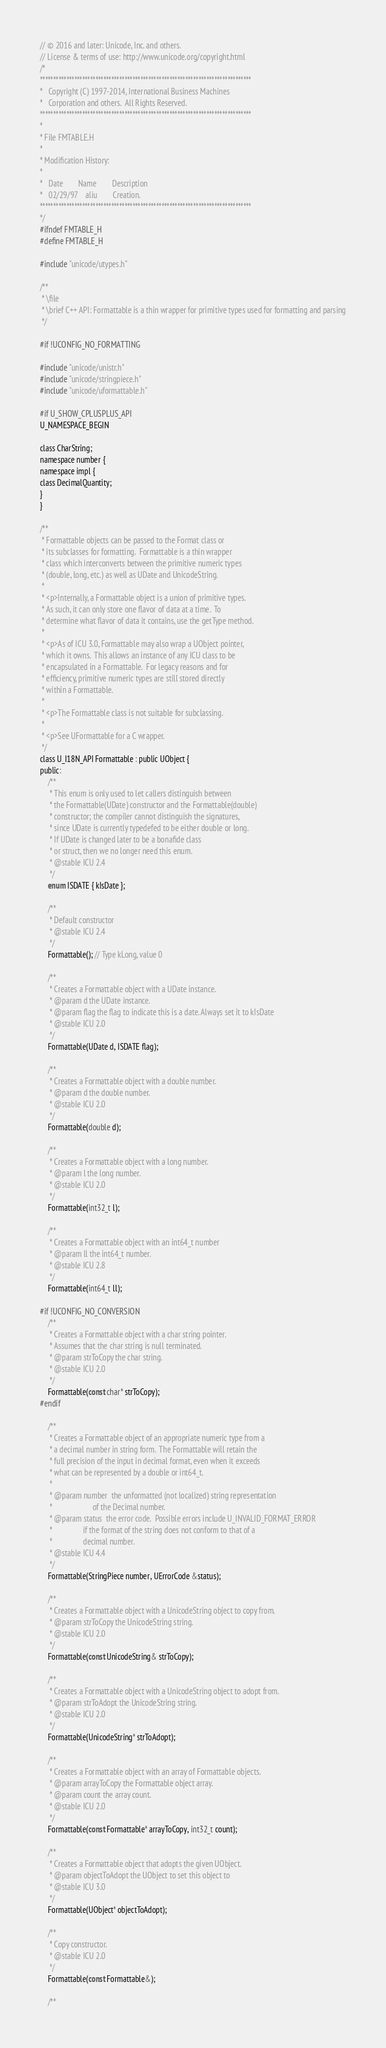Convert code to text. <code><loc_0><loc_0><loc_500><loc_500><_C_>// © 2016 and later: Unicode, Inc. and others.
// License & terms of use: http://www.unicode.org/copyright.html
/*
********************************************************************************
*   Copyright (C) 1997-2014, International Business Machines
*   Corporation and others.  All Rights Reserved.
********************************************************************************
*
* File FMTABLE.H
*
* Modification History:
*
*   Date        Name        Description
*   02/29/97    aliu        Creation.
********************************************************************************
*/
#ifndef FMTABLE_H
#define FMTABLE_H

#include "unicode/utypes.h"

/**
 * \file
 * \brief C++ API: Formattable is a thin wrapper for primitive types used for formatting and parsing
 */

#if !UCONFIG_NO_FORMATTING

#include "unicode/unistr.h"
#include "unicode/stringpiece.h"
#include "unicode/uformattable.h"

#if U_SHOW_CPLUSPLUS_API
U_NAMESPACE_BEGIN

class CharString;
namespace number {
namespace impl {
class DecimalQuantity;
}
}

/**
 * Formattable objects can be passed to the Format class or
 * its subclasses for formatting.  Formattable is a thin wrapper
 * class which interconverts between the primitive numeric types
 * (double, long, etc.) as well as UDate and UnicodeString.
 *
 * <p>Internally, a Formattable object is a union of primitive types.
 * As such, it can only store one flavor of data at a time.  To
 * determine what flavor of data it contains, use the getType method.
 *
 * <p>As of ICU 3.0, Formattable may also wrap a UObject pointer,
 * which it owns.  This allows an instance of any ICU class to be
 * encapsulated in a Formattable.  For legacy reasons and for
 * efficiency, primitive numeric types are still stored directly
 * within a Formattable.
 *
 * <p>The Formattable class is not suitable for subclassing.
 *
 * <p>See UFormattable for a C wrapper.
 */
class U_I18N_API Formattable : public UObject {
public:
    /**
     * This enum is only used to let callers distinguish between
     * the Formattable(UDate) constructor and the Formattable(double)
     * constructor; the compiler cannot distinguish the signatures,
     * since UDate is currently typedefed to be either double or long.
     * If UDate is changed later to be a bonafide class
     * or struct, then we no longer need this enum.
     * @stable ICU 2.4
     */
    enum ISDATE { kIsDate };

    /**
     * Default constructor
     * @stable ICU 2.4
     */
    Formattable(); // Type kLong, value 0

    /**
     * Creates a Formattable object with a UDate instance.
     * @param d the UDate instance.
     * @param flag the flag to indicate this is a date. Always set it to kIsDate
     * @stable ICU 2.0
     */
    Formattable(UDate d, ISDATE flag);

    /**
     * Creates a Formattable object with a double number.
     * @param d the double number.
     * @stable ICU 2.0
     */
    Formattable(double d);

    /**
     * Creates a Formattable object with a long number.
     * @param l the long number.
     * @stable ICU 2.0
     */
    Formattable(int32_t l);

    /**
     * Creates a Formattable object with an int64_t number
     * @param ll the int64_t number.
     * @stable ICU 2.8
     */
    Formattable(int64_t ll);

#if !UCONFIG_NO_CONVERSION
    /**
     * Creates a Formattable object with a char string pointer.
     * Assumes that the char string is null terminated.
     * @param strToCopy the char string.
     * @stable ICU 2.0
     */
    Formattable(const char* strToCopy);
#endif

    /**
     * Creates a Formattable object of an appropriate numeric type from a
     * a decimal number in string form.  The Formattable will retain the
     * full precision of the input in decimal format, even when it exceeds
     * what can be represented by a double or int64_t.
     *
     * @param number  the unformatted (not localized) string representation
     *                     of the Decimal number.
     * @param status  the error code.  Possible errors include U_INVALID_FORMAT_ERROR
     *                if the format of the string does not conform to that of a
     *                decimal number.
     * @stable ICU 4.4
     */
    Formattable(StringPiece number, UErrorCode &status);

    /**
     * Creates a Formattable object with a UnicodeString object to copy from.
     * @param strToCopy the UnicodeString string.
     * @stable ICU 2.0
     */
    Formattable(const UnicodeString& strToCopy);

    /**
     * Creates a Formattable object with a UnicodeString object to adopt from.
     * @param strToAdopt the UnicodeString string.
     * @stable ICU 2.0
     */
    Formattable(UnicodeString* strToAdopt);

    /**
     * Creates a Formattable object with an array of Formattable objects.
     * @param arrayToCopy the Formattable object array.
     * @param count the array count.
     * @stable ICU 2.0
     */
    Formattable(const Formattable* arrayToCopy, int32_t count);

    /**
     * Creates a Formattable object that adopts the given UObject.
     * @param objectToAdopt the UObject to set this object to
     * @stable ICU 3.0
     */
    Formattable(UObject* objectToAdopt);

    /**
     * Copy constructor.
     * @stable ICU 2.0
     */
    Formattable(const Formattable&);

    /**</code> 